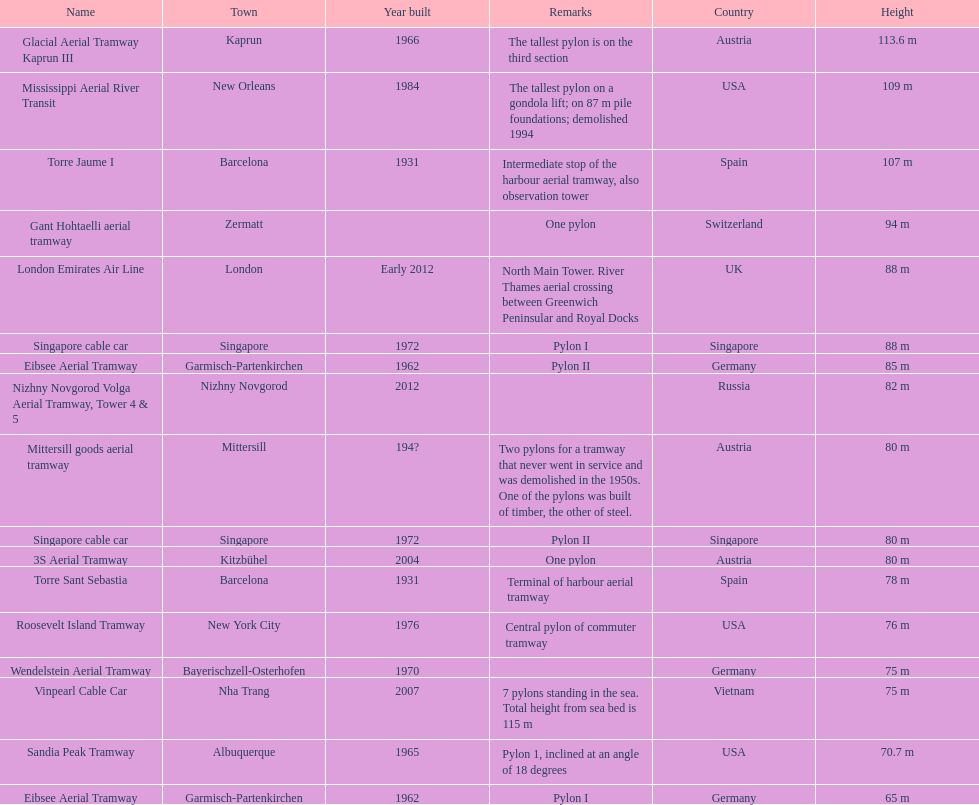What year was the last pylon in germany built? 1970. 